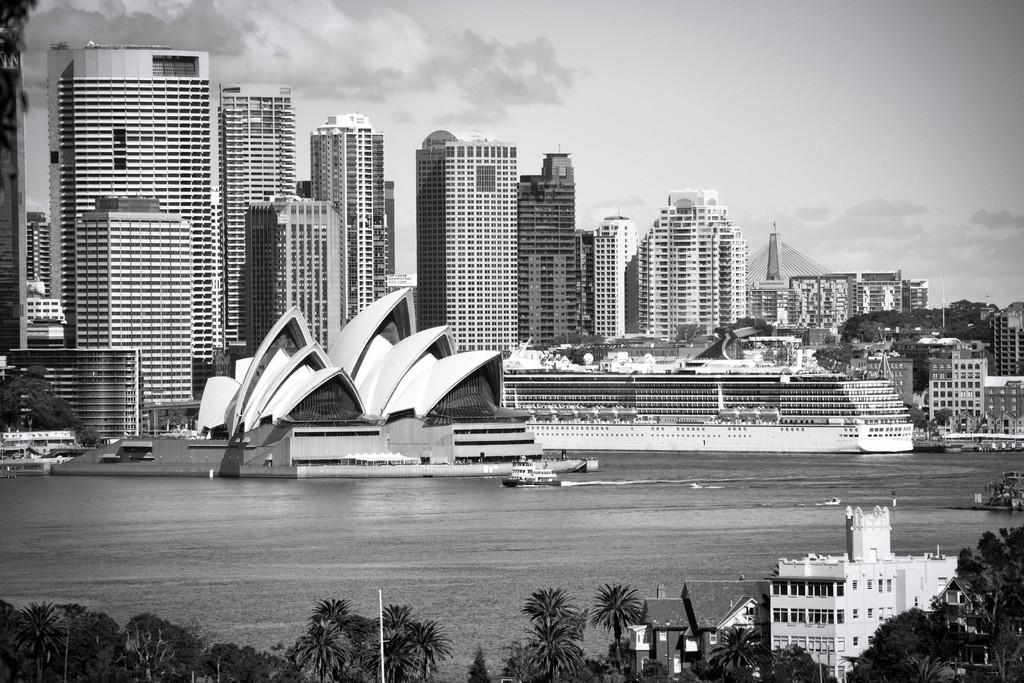What is the primary element in the image? There is water in the image. What is floating on the water? There is a boat in the water. What type of vegetation can be seen in the image? There are trees in the image. What type of man-made structures are present in the image? There are buildings in the image. What can be seen in the background of the image? The sky is visible in the background of the image. What type of nerve can be seen in the image? There is no nerve present in the image; it features water, a boat, trees, buildings, and the sky. 